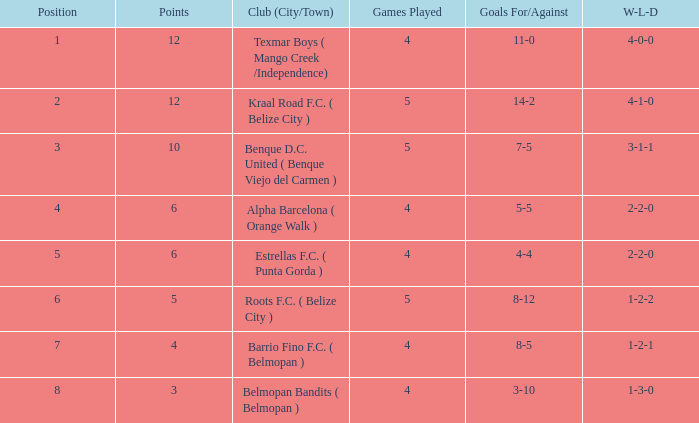What is the minimum games played with goals for/against being 7-5 5.0. 